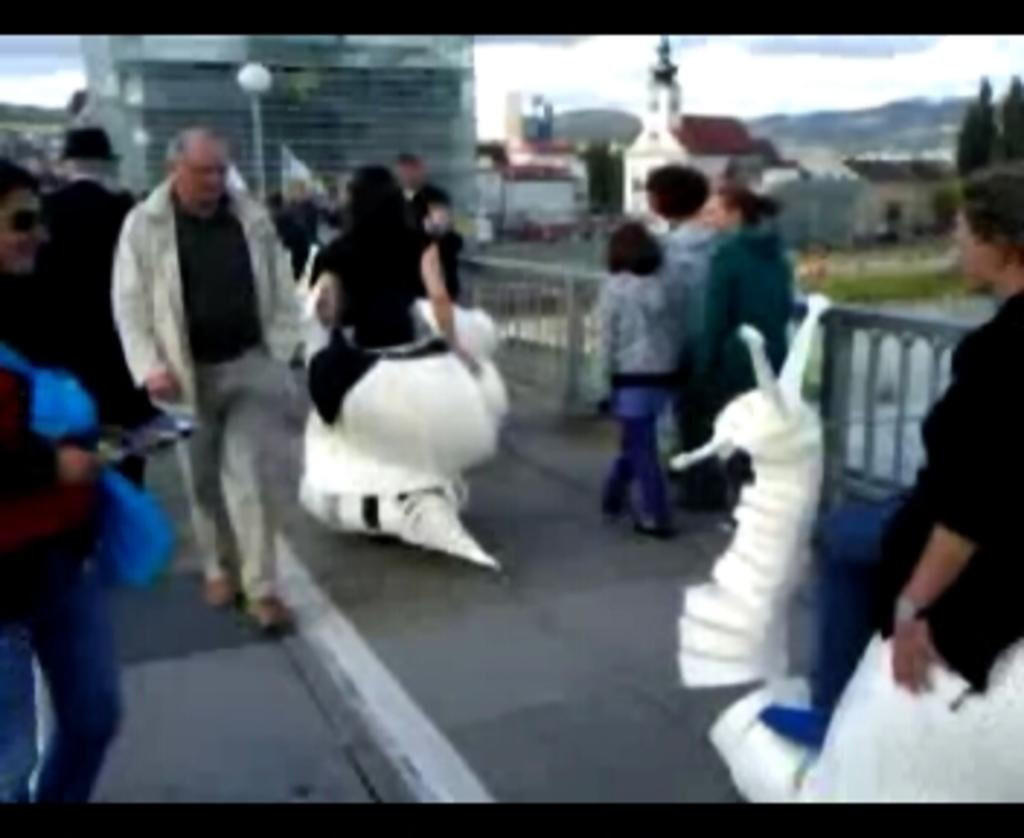How many people are in the image? There are people in the image, but the exact number is not specified. What is the main feature of the image? The main features of the image include a road, a fence, a pole, a light, buildings, trees, and the sky. What can be seen in the background of the image? The sky is visible in the background of the image, and there are clouds in the sky. What type of structures are present in the image? There are buildings in the image. What type of beef is being served at the event in the image? There is no event or beef present in the image. Can you see a ray of light shining through the trees in the image? There is no mention of a ray of light or trees being intertwined in the image. 